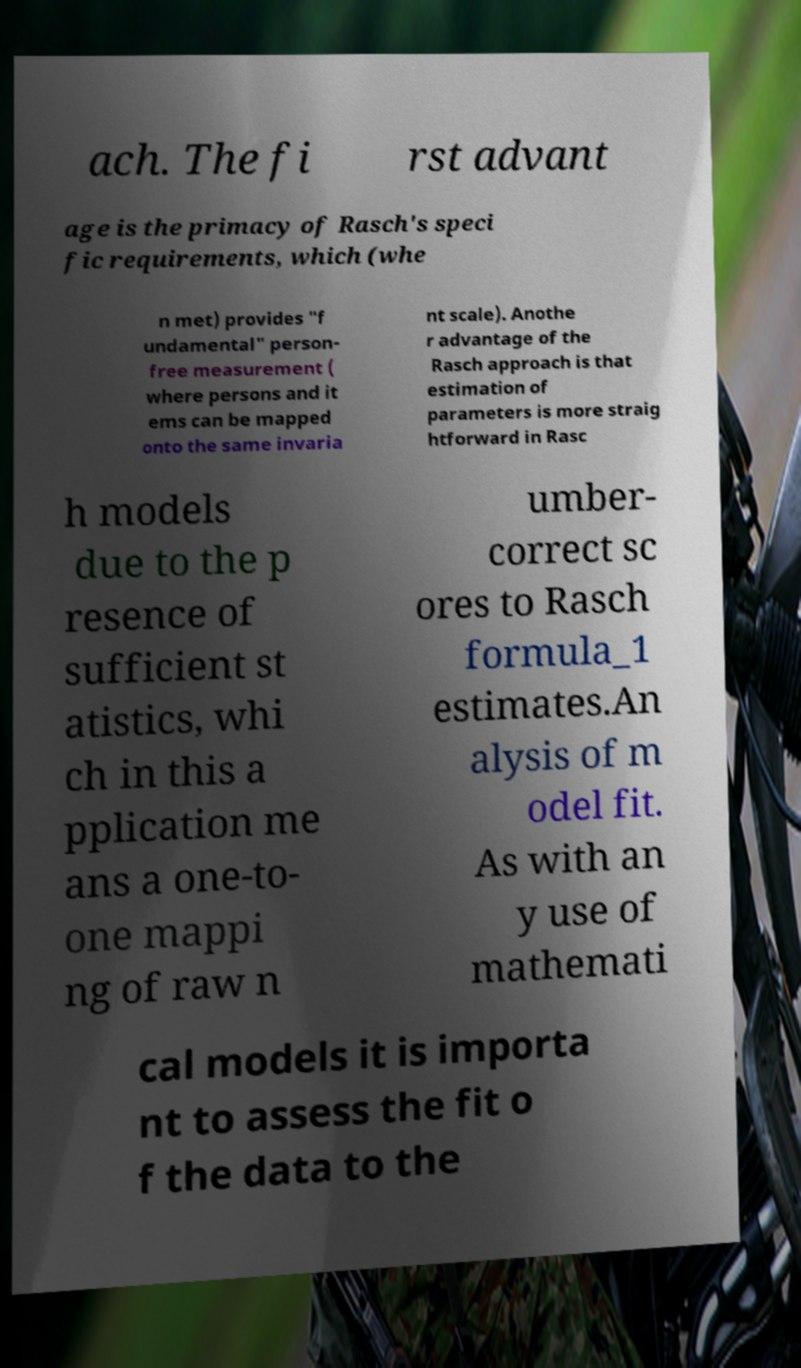I need the written content from this picture converted into text. Can you do that? ach. The fi rst advant age is the primacy of Rasch's speci fic requirements, which (whe n met) provides "f undamental" person- free measurement ( where persons and it ems can be mapped onto the same invaria nt scale). Anothe r advantage of the Rasch approach is that estimation of parameters is more straig htforward in Rasc h models due to the p resence of sufficient st atistics, whi ch in this a pplication me ans a one-to- one mappi ng of raw n umber- correct sc ores to Rasch formula_1 estimates.An alysis of m odel fit. As with an y use of mathemati cal models it is importa nt to assess the fit o f the data to the 